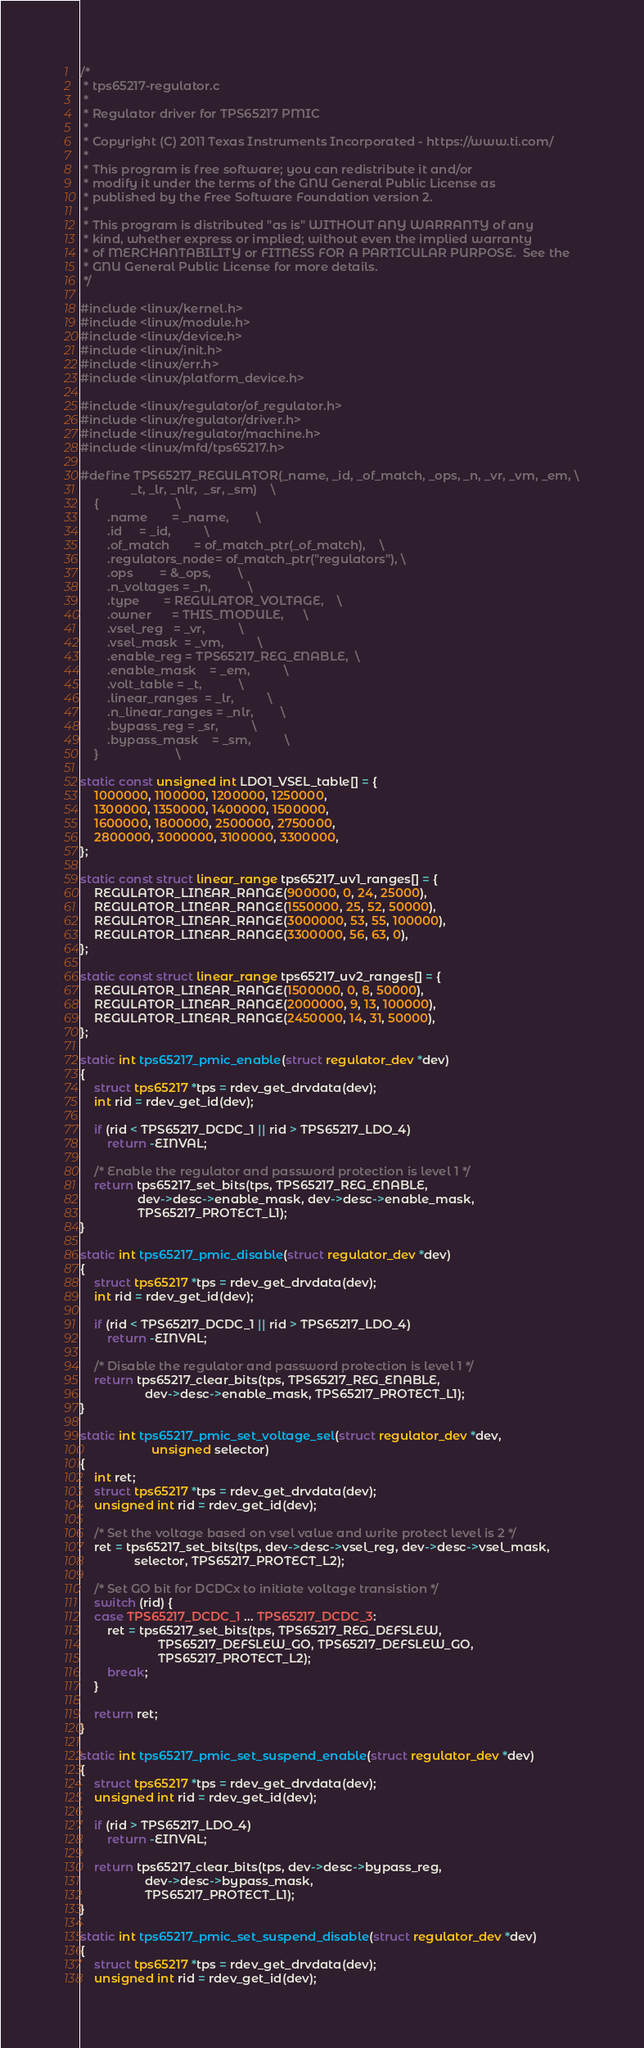Convert code to text. <code><loc_0><loc_0><loc_500><loc_500><_C_>/*
 * tps65217-regulator.c
 *
 * Regulator driver for TPS65217 PMIC
 *
 * Copyright (C) 2011 Texas Instruments Incorporated - https://www.ti.com/
 *
 * This program is free software; you can redistribute it and/or
 * modify it under the terms of the GNU General Public License as
 * published by the Free Software Foundation version 2.
 *
 * This program is distributed "as is" WITHOUT ANY WARRANTY of any
 * kind, whether express or implied; without even the implied warranty
 * of MERCHANTABILITY or FITNESS FOR A PARTICULAR PURPOSE.  See the
 * GNU General Public License for more details.
 */

#include <linux/kernel.h>
#include <linux/module.h>
#include <linux/device.h>
#include <linux/init.h>
#include <linux/err.h>
#include <linux/platform_device.h>

#include <linux/regulator/of_regulator.h>
#include <linux/regulator/driver.h>
#include <linux/regulator/machine.h>
#include <linux/mfd/tps65217.h>

#define TPS65217_REGULATOR(_name, _id, _of_match, _ops, _n, _vr, _vm, _em, \
			   _t, _lr, _nlr,  _sr, _sm)	\
	{						\
		.name		= _name,		\
		.id		= _id,			\
		.of_match       = of_match_ptr(_of_match),    \
		.regulators_node= of_match_ptr("regulators"), \
		.ops		= &_ops,		\
		.n_voltages	= _n,			\
		.type		= REGULATOR_VOLTAGE,	\
		.owner		= THIS_MODULE,		\
		.vsel_reg	= _vr,			\
		.vsel_mask	= _vm,			\
		.enable_reg	= TPS65217_REG_ENABLE,	\
		.enable_mask	= _em,			\
		.volt_table	= _t,			\
		.linear_ranges	= _lr,			\
		.n_linear_ranges = _nlr,		\
		.bypass_reg	= _sr,			\
		.bypass_mask	= _sm,			\
	}						\

static const unsigned int LDO1_VSEL_table[] = {
	1000000, 1100000, 1200000, 1250000,
	1300000, 1350000, 1400000, 1500000,
	1600000, 1800000, 2500000, 2750000,
	2800000, 3000000, 3100000, 3300000,
};

static const struct linear_range tps65217_uv1_ranges[] = {
	REGULATOR_LINEAR_RANGE(900000, 0, 24, 25000),
	REGULATOR_LINEAR_RANGE(1550000, 25, 52, 50000),
	REGULATOR_LINEAR_RANGE(3000000, 53, 55, 100000),
	REGULATOR_LINEAR_RANGE(3300000, 56, 63, 0),
};

static const struct linear_range tps65217_uv2_ranges[] = {
	REGULATOR_LINEAR_RANGE(1500000, 0, 8, 50000),
	REGULATOR_LINEAR_RANGE(2000000, 9, 13, 100000),
	REGULATOR_LINEAR_RANGE(2450000, 14, 31, 50000),
};

static int tps65217_pmic_enable(struct regulator_dev *dev)
{
	struct tps65217 *tps = rdev_get_drvdata(dev);
	int rid = rdev_get_id(dev);

	if (rid < TPS65217_DCDC_1 || rid > TPS65217_LDO_4)
		return -EINVAL;

	/* Enable the regulator and password protection is level 1 */
	return tps65217_set_bits(tps, TPS65217_REG_ENABLE,
				 dev->desc->enable_mask, dev->desc->enable_mask,
				 TPS65217_PROTECT_L1);
}

static int tps65217_pmic_disable(struct regulator_dev *dev)
{
	struct tps65217 *tps = rdev_get_drvdata(dev);
	int rid = rdev_get_id(dev);

	if (rid < TPS65217_DCDC_1 || rid > TPS65217_LDO_4)
		return -EINVAL;

	/* Disable the regulator and password protection is level 1 */
	return tps65217_clear_bits(tps, TPS65217_REG_ENABLE,
				   dev->desc->enable_mask, TPS65217_PROTECT_L1);
}

static int tps65217_pmic_set_voltage_sel(struct regulator_dev *dev,
					 unsigned selector)
{
	int ret;
	struct tps65217 *tps = rdev_get_drvdata(dev);
	unsigned int rid = rdev_get_id(dev);

	/* Set the voltage based on vsel value and write protect level is 2 */
	ret = tps65217_set_bits(tps, dev->desc->vsel_reg, dev->desc->vsel_mask,
				selector, TPS65217_PROTECT_L2);

	/* Set GO bit for DCDCx to initiate voltage transistion */
	switch (rid) {
	case TPS65217_DCDC_1 ... TPS65217_DCDC_3:
		ret = tps65217_set_bits(tps, TPS65217_REG_DEFSLEW,
				       TPS65217_DEFSLEW_GO, TPS65217_DEFSLEW_GO,
				       TPS65217_PROTECT_L2);
		break;
	}

	return ret;
}

static int tps65217_pmic_set_suspend_enable(struct regulator_dev *dev)
{
	struct tps65217 *tps = rdev_get_drvdata(dev);
	unsigned int rid = rdev_get_id(dev);

	if (rid > TPS65217_LDO_4)
		return -EINVAL;

	return tps65217_clear_bits(tps, dev->desc->bypass_reg,
				   dev->desc->bypass_mask,
				   TPS65217_PROTECT_L1);
}

static int tps65217_pmic_set_suspend_disable(struct regulator_dev *dev)
{
	struct tps65217 *tps = rdev_get_drvdata(dev);
	unsigned int rid = rdev_get_id(dev);
</code> 